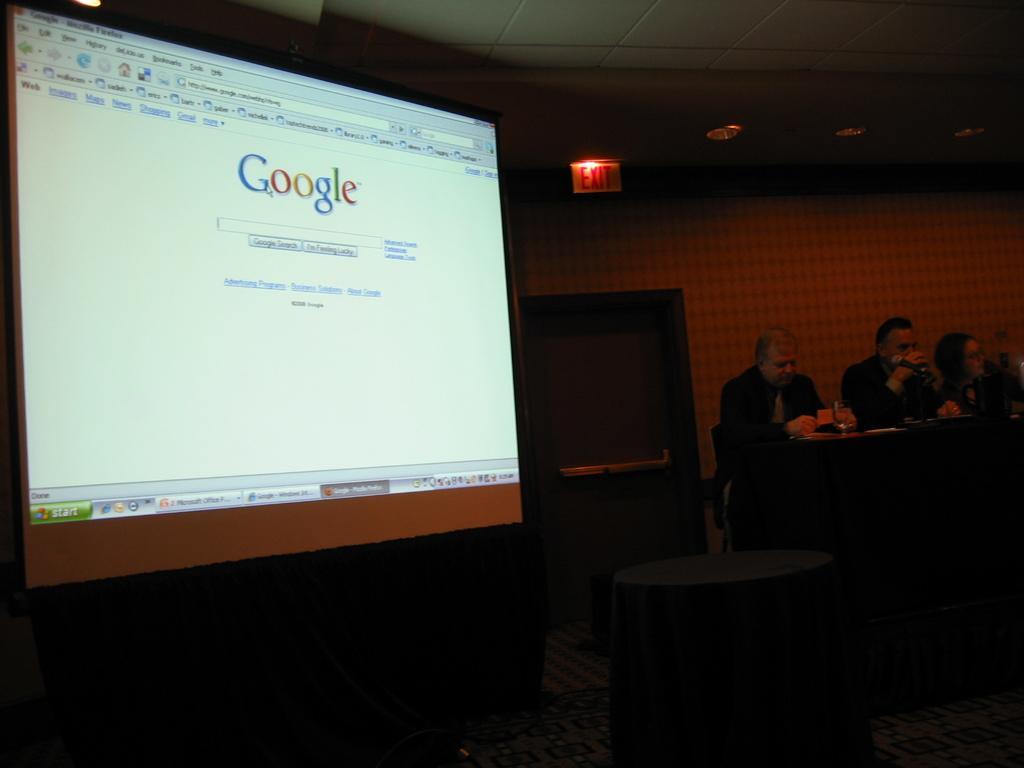Please provide a concise description of this image. In this image there are group of people sitting in chairs near table and on table there are glasses, papers and in the back ground there is screen, door, name board, light. 